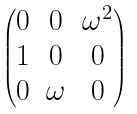Convert formula to latex. <formula><loc_0><loc_0><loc_500><loc_500>\begin{pmatrix} 0 & 0 & \omega ^ { 2 } \\ 1 & 0 & 0 \\ 0 & \omega & 0 \\ \end{pmatrix}</formula> 